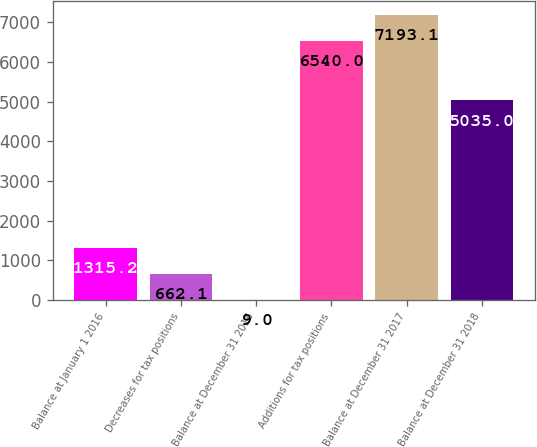Convert chart. <chart><loc_0><loc_0><loc_500><loc_500><bar_chart><fcel>Balance at January 1 2016<fcel>Decreases for tax positions<fcel>Balance at December 31 2016<fcel>Additions for tax positions<fcel>Balance at December 31 2017<fcel>Balance at December 31 2018<nl><fcel>1315.2<fcel>662.1<fcel>9<fcel>6540<fcel>7193.1<fcel>5035<nl></chart> 